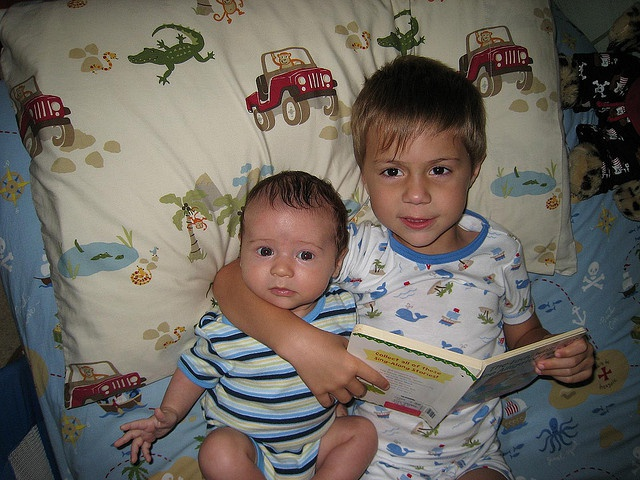Describe the objects in this image and their specific colors. I can see bed in black, darkgray, and gray tones, people in black, darkgray, and gray tones, people in black, brown, gray, and darkgray tones, and book in black, darkgray, and gray tones in this image. 